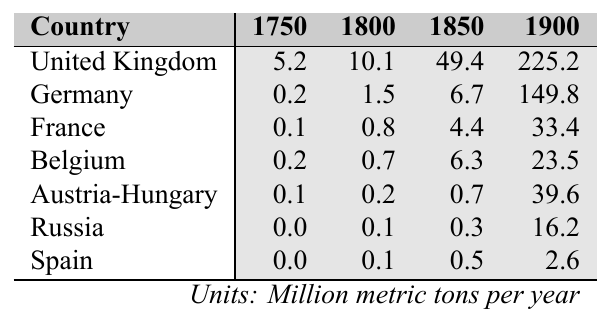What was the coal production in the United Kingdom in 1900? The table shows that the coal production in the United Kingdom in 1900 was 225.2 million metric tons per year.
Answer: 225.2 Which country had the highest coal production in 1850? Upon reviewing the table, the United Kingdom had the highest coal production in 1850, with 49.4 million metric tons per year.
Answer: United Kingdom What is the total coal production of France and Belgium in 1900? The coal production for France in 1900 was 33.4 million metric tons and for Belgium, it was 23.5 million metric tons. Summing these values (33.4 + 23.5), gives us a total of 56.9 million metric tons.
Answer: 56.9 Did Spain produce more coal than Austria-Hungary in 1850? In 1850, Spain produced 0.5 million metric tons while Austria-Hungary produced 0.7 million metric tons. Since 0.5 < 0.7, the answer is no.
Answer: No What was the increase in coal production in Germany from 1800 to 1900? The coal production in Germany was 1.5 million metric tons in 1800 and increased to 149.8 million metric tons in 1900. The difference is (149.8 - 1.5) = 148.3 million metric tons.
Answer: 148.3 Which country had the lowest coal production in 1750? According to the table, Russia produced 0.0 million metric tons in 1750, indicating it had the lowest coal production.
Answer: Russia What is the average coal production of all countries in 1900? The coal production values for 1900 are: United Kingdom (225.2), Germany (149.8), France (33.4), Belgium (23.5), Austria-Hungary (39.6), Russia (16.2), and Spain (2.6). Summing these values gives us 225.2 + 149.8 + 33.4 + 23.5 + 39.6 + 16.2 + 2.6 = 490.3 million metric tons. Dividing this by 7 countries gives us an average of (490.3 / 7) ≈ 70.04 million metric tons.
Answer: 70.04 How much coal did Russia produce in 1800 compared to France? Russia produced 0.1 million metric tons in 1800, while France produced 0.8 million metric tons. Comparing these values shows that 0.1 < 0.8.
Answer: No What was the overall growth of coal production from 1750 to 1900 in the United Kingdom? The coal production in the United Kingdom was 5.2 million metric tons in 1750 and grew to 225.2 million metric tons in 1900. The overall growth is (225.2 - 5.2), which equals 220 million metric tons.
Answer: 220 If Austria-Hungary's production increases by 10 million metric tons per year after 1900, what would its production be in 1905? The coal production for Austria-Hungary in 1900 was 39.6 million metric tons. Adding the 10 million metric tons increase for 5 years results in (39.6 + 10 * 5) = 89.6 million metric tons in 1905.
Answer: 89.6 